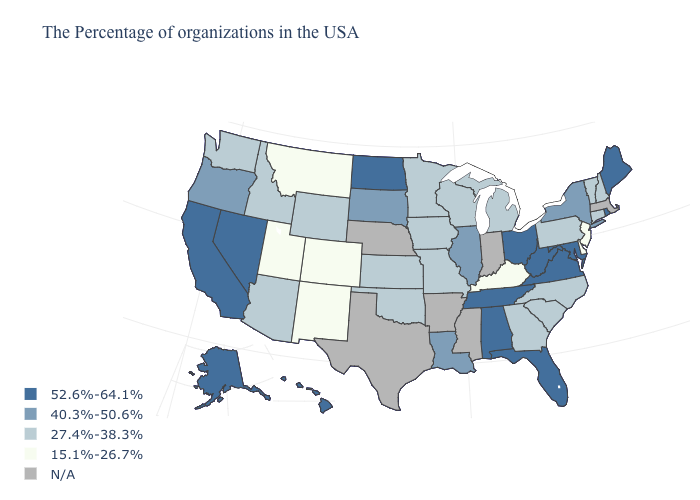Does Delaware have the lowest value in the South?
Write a very short answer. Yes. What is the value of Michigan?
Be succinct. 27.4%-38.3%. Which states have the lowest value in the MidWest?
Write a very short answer. Michigan, Wisconsin, Missouri, Minnesota, Iowa, Kansas. What is the lowest value in states that border Georgia?
Give a very brief answer. 27.4%-38.3%. Does Ohio have the lowest value in the MidWest?
Keep it brief. No. Name the states that have a value in the range N/A?
Keep it brief. Massachusetts, Indiana, Mississippi, Arkansas, Nebraska, Texas. Does New Hampshire have the lowest value in the USA?
Be succinct. No. What is the highest value in the USA?
Write a very short answer. 52.6%-64.1%. What is the value of South Dakota?
Be succinct. 40.3%-50.6%. Does Alabama have the highest value in the USA?
Concise answer only. Yes. What is the highest value in states that border Indiana?
Concise answer only. 52.6%-64.1%. Does the map have missing data?
Write a very short answer. Yes. Name the states that have a value in the range N/A?
Concise answer only. Massachusetts, Indiana, Mississippi, Arkansas, Nebraska, Texas. 